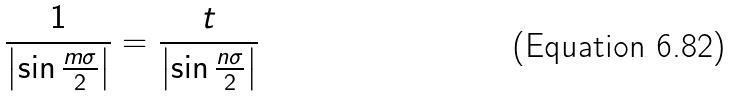<formula> <loc_0><loc_0><loc_500><loc_500>\frac { 1 } { \left | \sin \frac { m \sigma } { 2 } \right | } = \frac { t } { \left | \sin \frac { n \sigma } { 2 } \right | }</formula> 